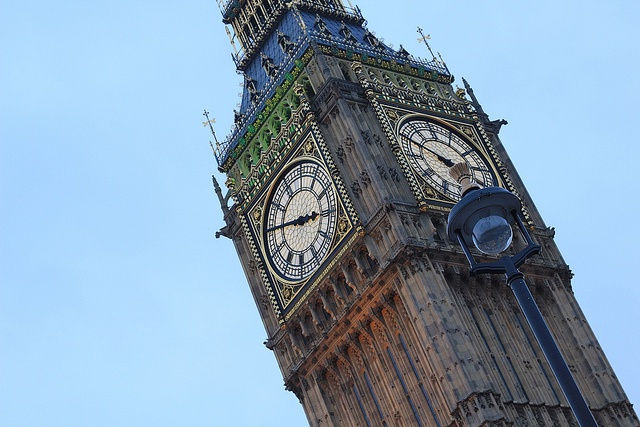Describe the objects in this image and their specific colors. I can see clock in lightblue, lightgray, black, darkgray, and gray tones and clock in lightblue, black, darkgray, lightgray, and gray tones in this image. 